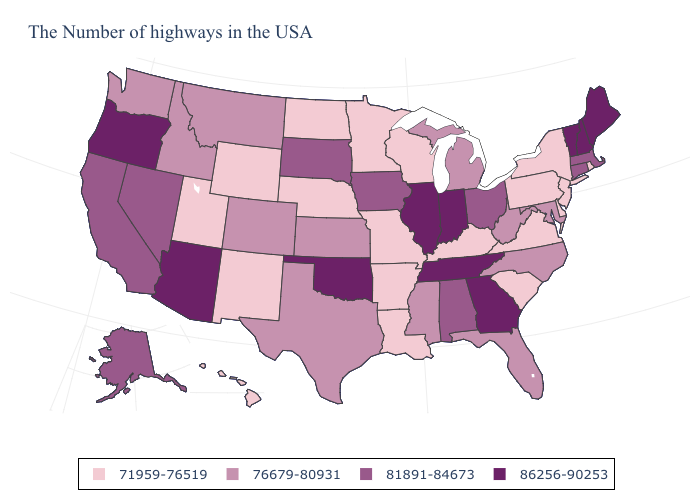Which states have the lowest value in the West?
Give a very brief answer. Wyoming, New Mexico, Utah, Hawaii. What is the value of Iowa?
Keep it brief. 81891-84673. Does the first symbol in the legend represent the smallest category?
Quick response, please. Yes. Name the states that have a value in the range 81891-84673?
Be succinct. Massachusetts, Connecticut, Ohio, Alabama, Iowa, South Dakota, Nevada, California, Alaska. What is the lowest value in states that border Rhode Island?
Short answer required. 81891-84673. Does Washington have a lower value than Illinois?
Concise answer only. Yes. Name the states that have a value in the range 71959-76519?
Write a very short answer. Rhode Island, New York, New Jersey, Delaware, Pennsylvania, Virginia, South Carolina, Kentucky, Wisconsin, Louisiana, Missouri, Arkansas, Minnesota, Nebraska, North Dakota, Wyoming, New Mexico, Utah, Hawaii. Which states have the lowest value in the USA?
Answer briefly. Rhode Island, New York, New Jersey, Delaware, Pennsylvania, Virginia, South Carolina, Kentucky, Wisconsin, Louisiana, Missouri, Arkansas, Minnesota, Nebraska, North Dakota, Wyoming, New Mexico, Utah, Hawaii. Which states have the highest value in the USA?
Answer briefly. Maine, New Hampshire, Vermont, Georgia, Indiana, Tennessee, Illinois, Oklahoma, Arizona, Oregon. Does the first symbol in the legend represent the smallest category?
Keep it brief. Yes. Name the states that have a value in the range 86256-90253?
Be succinct. Maine, New Hampshire, Vermont, Georgia, Indiana, Tennessee, Illinois, Oklahoma, Arizona, Oregon. Among the states that border Iowa , does Illinois have the highest value?
Concise answer only. Yes. What is the highest value in the MidWest ?
Give a very brief answer. 86256-90253. Among the states that border Ohio , does West Virginia have the highest value?
Answer briefly. No. Name the states that have a value in the range 71959-76519?
Write a very short answer. Rhode Island, New York, New Jersey, Delaware, Pennsylvania, Virginia, South Carolina, Kentucky, Wisconsin, Louisiana, Missouri, Arkansas, Minnesota, Nebraska, North Dakota, Wyoming, New Mexico, Utah, Hawaii. 